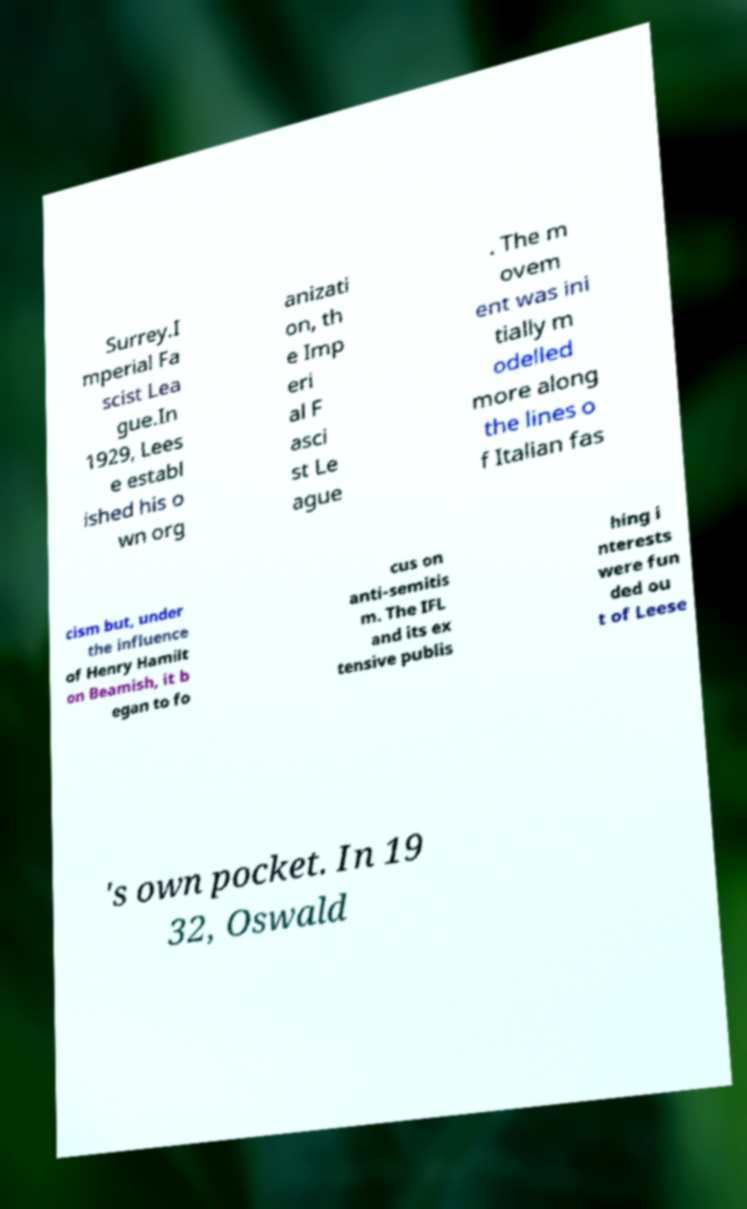I need the written content from this picture converted into text. Can you do that? Surrey.I mperial Fa scist Lea gue.In 1929, Lees e establ ished his o wn org anizati on, th e Imp eri al F asci st Le ague . The m ovem ent was ini tially m odelled more along the lines o f Italian fas cism but, under the influence of Henry Hamilt on Beamish, it b egan to fo cus on anti-semitis m. The IFL and its ex tensive publis hing i nterests were fun ded ou t of Leese 's own pocket. In 19 32, Oswald 